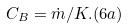<formula> <loc_0><loc_0><loc_500><loc_500>C _ { B } = \dot { m } / K . ( 6 a )</formula> 